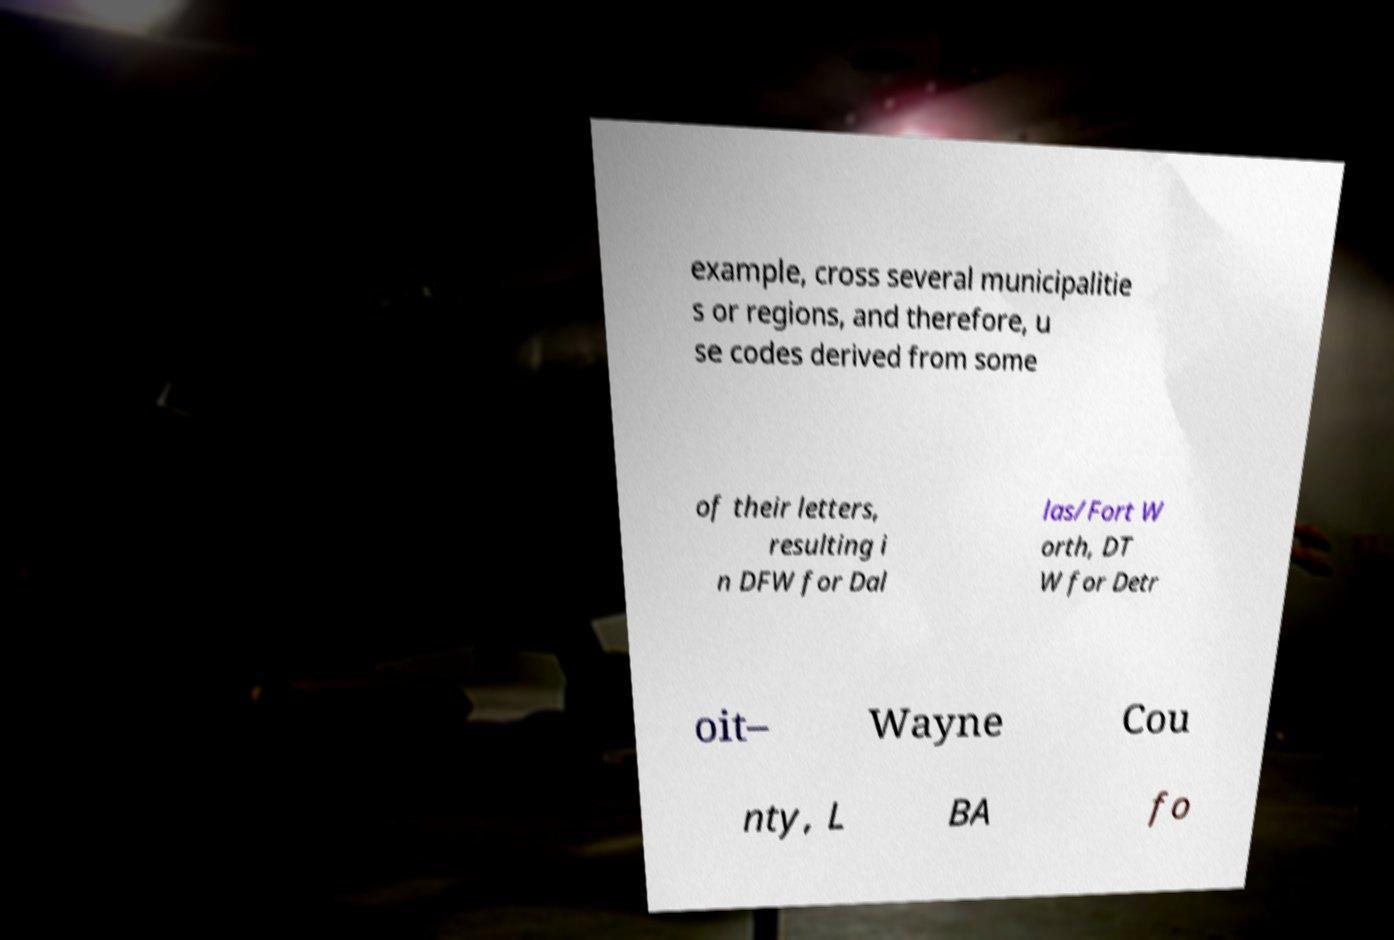There's text embedded in this image that I need extracted. Can you transcribe it verbatim? example, cross several municipalitie s or regions, and therefore, u se codes derived from some of their letters, resulting i n DFW for Dal las/Fort W orth, DT W for Detr oit– Wayne Cou nty, L BA fo 